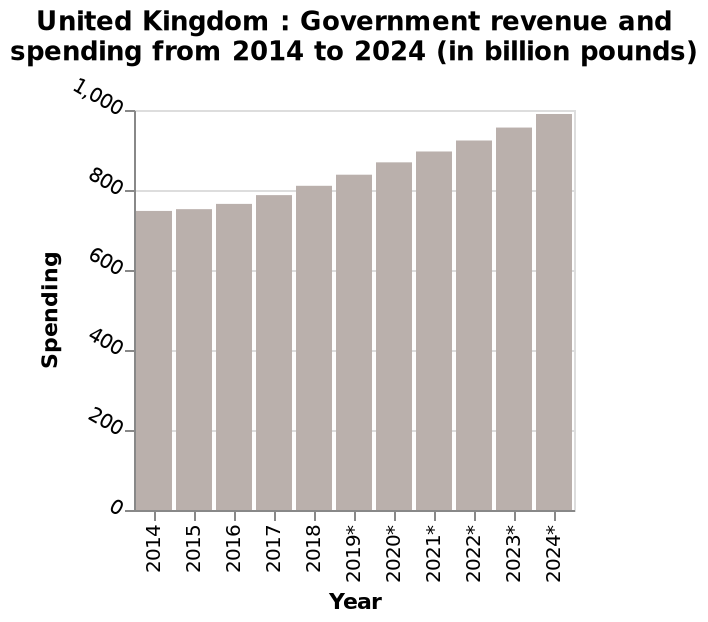<image>
What does the bar diagram show about the United Kingdom? The bar diagram shows the government revenue and spending for the United Kingdom from 2014 to 2024 in billion pounds. please describe the details of the chart This is a bar diagram labeled United Kingdom : Government revenue and spending from 2014 to 2024 (in billion pounds). The x-axis plots Year while the y-axis measures Spending. 